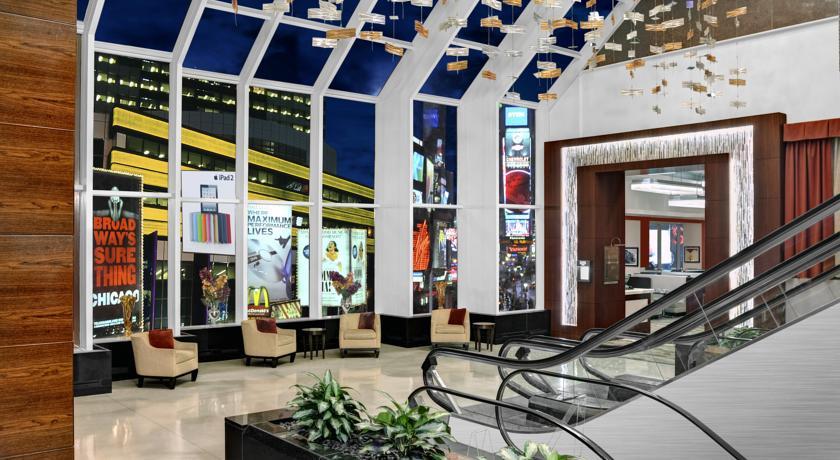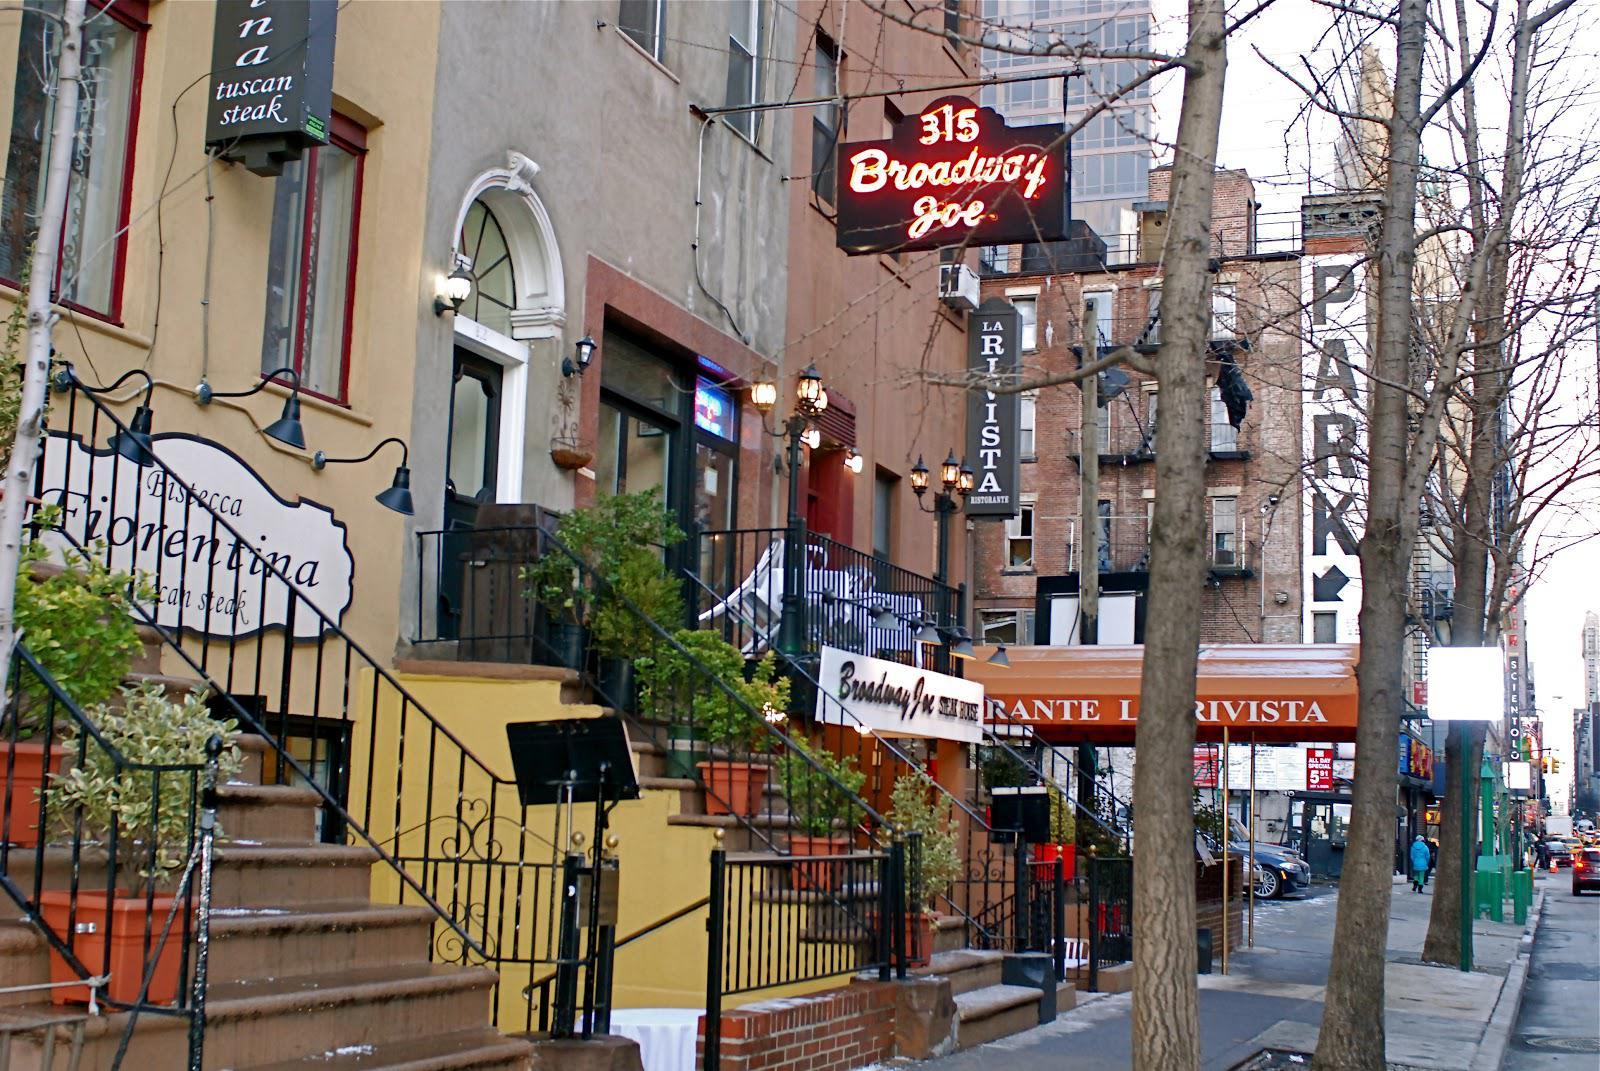The first image is the image on the left, the second image is the image on the right. Considering the images on both sides, is "It is night in the right image, with lots of lit up buildings." valid? Answer yes or no. No. The first image is the image on the left, the second image is the image on the right. Evaluate the accuracy of this statement regarding the images: "There are at least four yellow taxi cabs.". Is it true? Answer yes or no. No. 